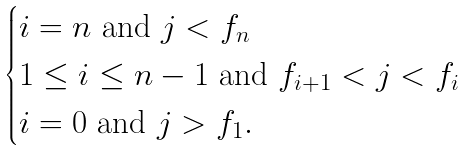<formula> <loc_0><loc_0><loc_500><loc_500>\begin{cases} i = n \text { and } j < f _ { n } \\ 1 \leq i \leq n - 1 \text { and } f _ { i + 1 } < j < f _ { i } \\ i = 0 \text { and } j > f _ { 1 } . \end{cases}</formula> 